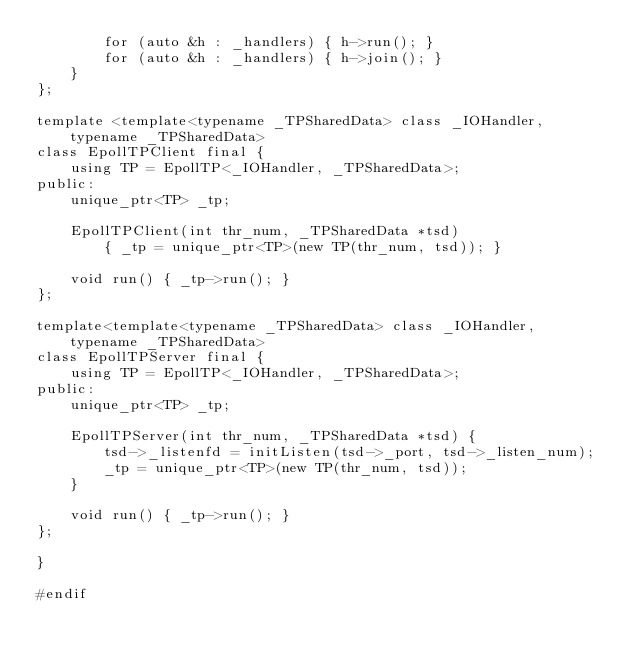Convert code to text. <code><loc_0><loc_0><loc_500><loc_500><_C_>        for (auto &h : _handlers) { h->run(); }
        for (auto &h : _handlers) { h->join(); }
    }
};

template <template<typename _TPSharedData> class _IOHandler,
    typename _TPSharedData>
class EpollTPClient final {
    using TP = EpollTP<_IOHandler, _TPSharedData>;
public:
    unique_ptr<TP> _tp;

    EpollTPClient(int thr_num, _TPSharedData *tsd)
        { _tp = unique_ptr<TP>(new TP(thr_num, tsd)); }

    void run() { _tp->run(); }
};

template<template<typename _TPSharedData> class _IOHandler,
    typename _TPSharedData>
class EpollTPServer final {
    using TP = EpollTP<_IOHandler, _TPSharedData>;
public:
    unique_ptr<TP> _tp;

    EpollTPServer(int thr_num, _TPSharedData *tsd) {
        tsd->_listenfd = initListen(tsd->_port, tsd->_listen_num);
        _tp = unique_ptr<TP>(new TP(thr_num, tsd));
    }

    void run() { _tp->run(); }
};

}

#endif
</code> 